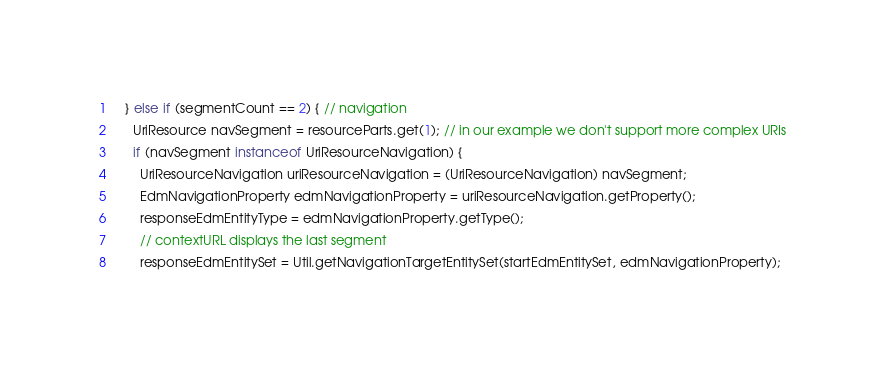<code> <loc_0><loc_0><loc_500><loc_500><_Java_>    } else if (segmentCount == 2) { // navigation
      UriResource navSegment = resourceParts.get(1); // in our example we don't support more complex URIs
      if (navSegment instanceof UriResourceNavigation) {
        UriResourceNavigation uriResourceNavigation = (UriResourceNavigation) navSegment;
        EdmNavigationProperty edmNavigationProperty = uriResourceNavigation.getProperty();
        responseEdmEntityType = edmNavigationProperty.getType();
        // contextURL displays the last segment
        responseEdmEntitySet = Util.getNavigationTargetEntitySet(startEdmEntitySet, edmNavigationProperty);
</code> 